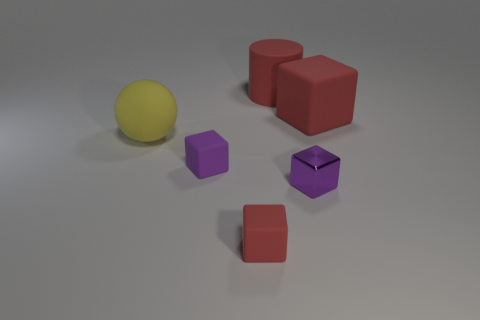Add 3 big cyan rubber cylinders. How many objects exist? 9 Subtract all cylinders. How many objects are left? 5 Subtract 0 green spheres. How many objects are left? 6 Subtract all red rubber things. Subtract all red rubber cylinders. How many objects are left? 2 Add 1 large yellow spheres. How many large yellow spheres are left? 2 Add 4 purple blocks. How many purple blocks exist? 6 